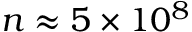<formula> <loc_0><loc_0><loc_500><loc_500>n \approx 5 \times 1 0 ^ { 8 }</formula> 